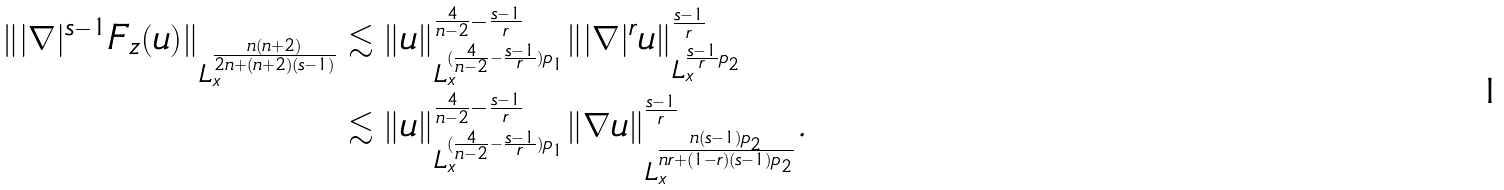<formula> <loc_0><loc_0><loc_500><loc_500>\| | \nabla | ^ { s - 1 } F _ { z } ( u ) \| _ { L _ { x } ^ { \frac { n ( n + 2 ) } { 2 n + ( n + 2 ) ( s - 1 ) } } } & \lesssim \| u \| ^ { \frac { 4 } { n - 2 } - \frac { s - 1 } { r } } _ { L _ { x } ^ { ( \frac { 4 } { n - 2 } - \frac { s - 1 } { r } ) p _ { 1 } } } \| | \nabla | ^ { r } u \| ^ { \frac { s - 1 } { r } } _ { L _ { x } ^ { \frac { s - 1 } { r } p _ { 2 } } } \\ & \lesssim \| u \| ^ { \frac { 4 } { n - 2 } - \frac { s - 1 } { r } } _ { L _ { x } ^ { ( \frac { 4 } { n - 2 } - \frac { s - 1 } { r } ) p _ { 1 } } } \| \nabla u \| ^ { \frac { s - 1 } { r } } _ { L _ { x } ^ { \frac { n ( s - 1 ) p _ { 2 } } { n r + ( 1 - r ) ( s - 1 ) p _ { 2 } } } } .</formula> 